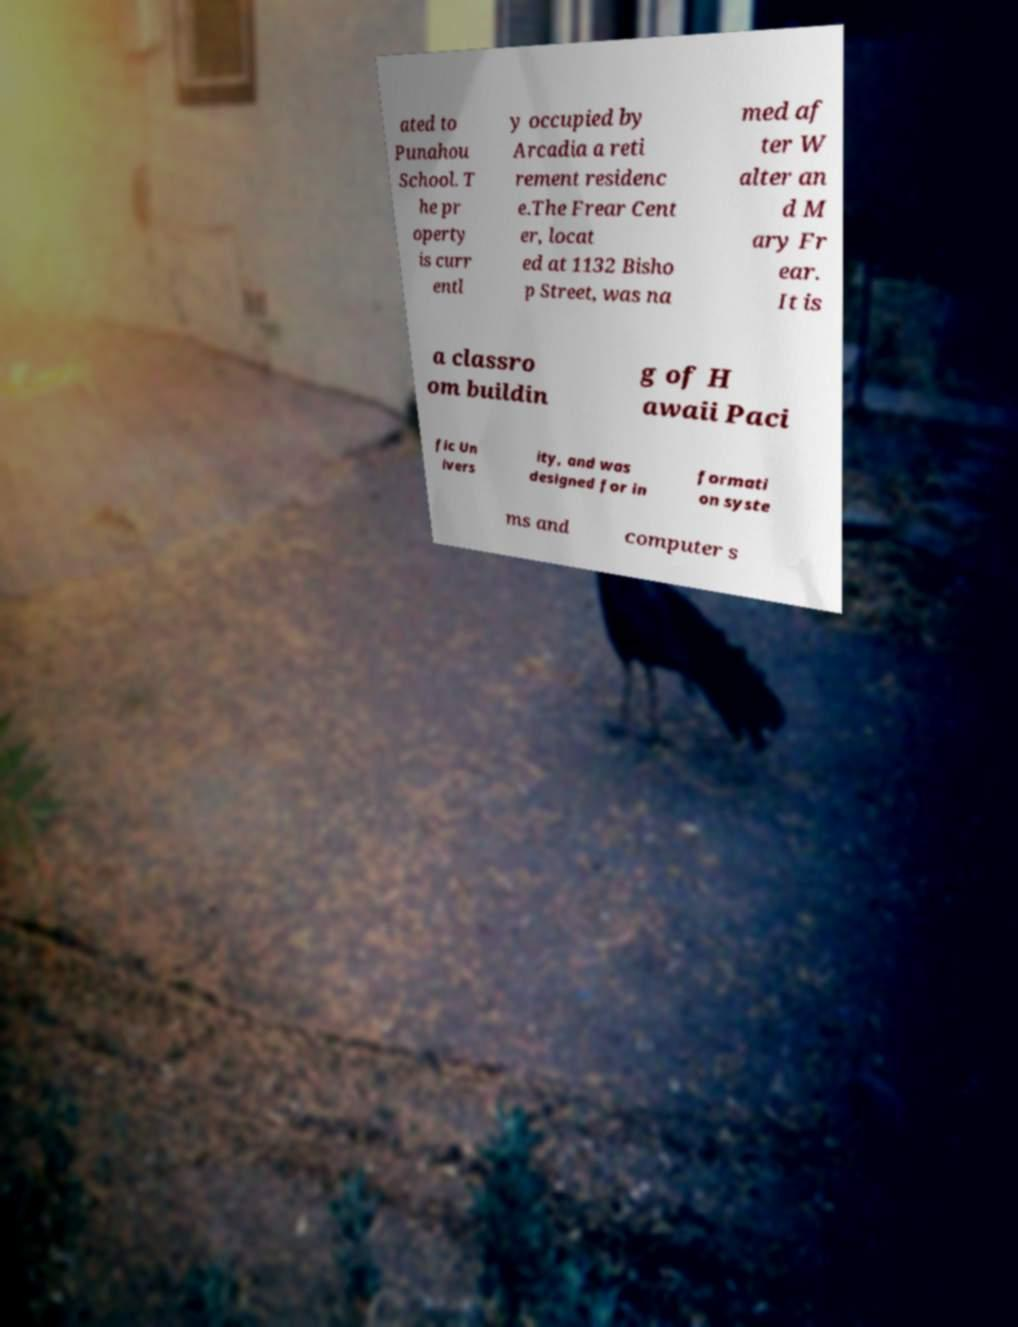I need the written content from this picture converted into text. Can you do that? ated to Punahou School. T he pr operty is curr entl y occupied by Arcadia a reti rement residenc e.The Frear Cent er, locat ed at 1132 Bisho p Street, was na med af ter W alter an d M ary Fr ear. It is a classro om buildin g of H awaii Paci fic Un ivers ity, and was designed for in formati on syste ms and computer s 